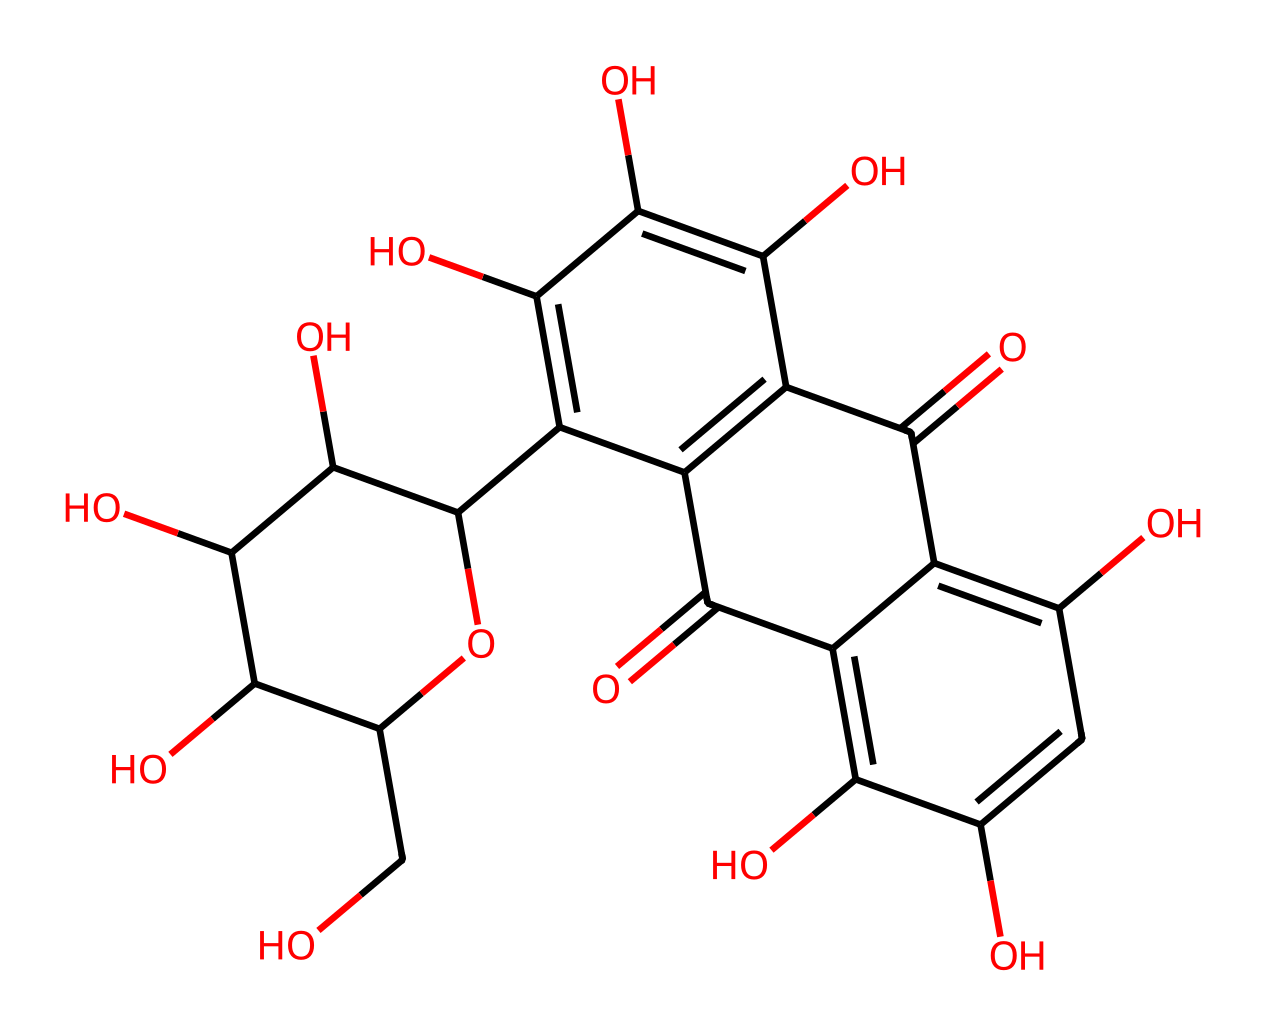how many carbon atoms are present in carmine red? By examining the SMILES representation, I can count the carbon atoms. The notation contains 26 carbon atoms as indicated by the 'C' symbols before other components.
Answer: 26 what is the functional group in carmine red that indicates its acidity? The presence of multiple hydroxyl groups (-OH) in the structure signifies its acidic properties. These groups can donate protons, making it acidic.
Answer: hydroxyl how many hydroxyl groups are present in carmine red? Inspecting the structure, I can identify 6 hydroxyl (OH) groups dispersed throughout the molecule.
Answer: 6 what is the main type of bonding present in the carmine red structure? The structure primarily features covalent bonds, as indicated by the sharing of electrons between the carbon atoms and other functional groups in the molecule.
Answer: covalent which part of carmine red contributes to its red color? The specific arrangement of conjugated double bonds in the aromatic rings results in the absorption of certain light wavelengths, contributing to the red color.
Answer: aromatic rings what is the molecular weight of carmine red? By calculating the molecular weight based on the number of each type of atom present and their respective weights, carmine red has a molecular weight of approximately 492.4 g/mol.
Answer: 492.4 